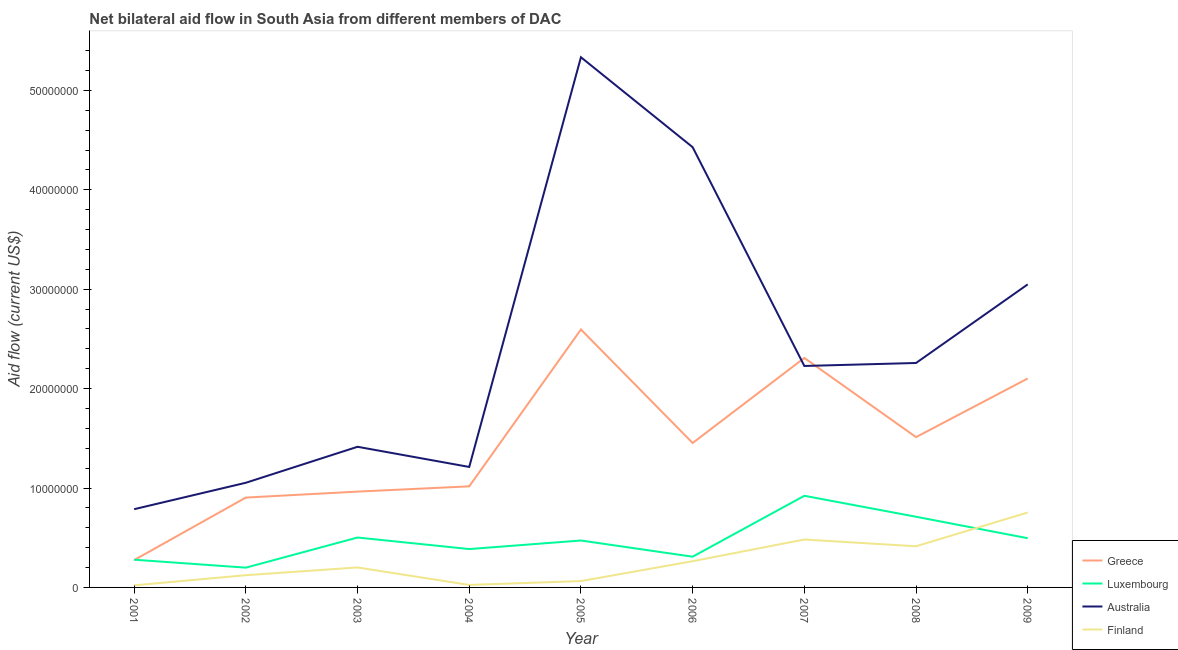What is the amount of aid given by finland in 2003?
Ensure brevity in your answer.  2.01e+06. Across all years, what is the maximum amount of aid given by australia?
Keep it short and to the point. 5.33e+07. Across all years, what is the minimum amount of aid given by finland?
Ensure brevity in your answer.  2.10e+05. In which year was the amount of aid given by greece maximum?
Make the answer very short. 2005. What is the total amount of aid given by greece in the graph?
Provide a succinct answer. 1.31e+08. What is the difference between the amount of aid given by luxembourg in 2003 and that in 2007?
Provide a succinct answer. -4.20e+06. What is the difference between the amount of aid given by australia in 2003 and the amount of aid given by finland in 2008?
Your answer should be compact. 1.00e+07. What is the average amount of aid given by luxembourg per year?
Offer a very short reply. 4.75e+06. In the year 2006, what is the difference between the amount of aid given by greece and amount of aid given by finland?
Provide a succinct answer. 1.19e+07. In how many years, is the amount of aid given by australia greater than 14000000 US$?
Offer a terse response. 6. What is the ratio of the amount of aid given by greece in 2002 to that in 2003?
Provide a succinct answer. 0.94. Is the amount of aid given by finland in 2002 less than that in 2007?
Provide a succinct answer. Yes. Is the difference between the amount of aid given by finland in 2003 and 2008 greater than the difference between the amount of aid given by australia in 2003 and 2008?
Keep it short and to the point. Yes. What is the difference between the highest and the second highest amount of aid given by luxembourg?
Your answer should be compact. 2.11e+06. What is the difference between the highest and the lowest amount of aid given by australia?
Give a very brief answer. 4.55e+07. In how many years, is the amount of aid given by greece greater than the average amount of aid given by greece taken over all years?
Give a very brief answer. 4. Is the sum of the amount of aid given by luxembourg in 2001 and 2004 greater than the maximum amount of aid given by greece across all years?
Offer a very short reply. No. Is it the case that in every year, the sum of the amount of aid given by greece and amount of aid given by luxembourg is greater than the amount of aid given by australia?
Give a very brief answer. No. Does the amount of aid given by australia monotonically increase over the years?
Provide a short and direct response. No. Does the graph contain any zero values?
Offer a very short reply. No. Does the graph contain grids?
Offer a terse response. No. How many legend labels are there?
Offer a terse response. 4. How are the legend labels stacked?
Provide a short and direct response. Vertical. What is the title of the graph?
Offer a very short reply. Net bilateral aid flow in South Asia from different members of DAC. What is the Aid flow (current US$) in Greece in 2001?
Keep it short and to the point. 2.75e+06. What is the Aid flow (current US$) of Luxembourg in 2001?
Offer a terse response. 2.79e+06. What is the Aid flow (current US$) of Australia in 2001?
Make the answer very short. 7.87e+06. What is the Aid flow (current US$) in Finland in 2001?
Your answer should be compact. 2.10e+05. What is the Aid flow (current US$) of Greece in 2002?
Provide a succinct answer. 9.04e+06. What is the Aid flow (current US$) in Luxembourg in 2002?
Your response must be concise. 1.99e+06. What is the Aid flow (current US$) of Australia in 2002?
Offer a terse response. 1.05e+07. What is the Aid flow (current US$) of Finland in 2002?
Offer a terse response. 1.23e+06. What is the Aid flow (current US$) of Greece in 2003?
Keep it short and to the point. 9.64e+06. What is the Aid flow (current US$) in Luxembourg in 2003?
Your response must be concise. 5.02e+06. What is the Aid flow (current US$) of Australia in 2003?
Offer a terse response. 1.42e+07. What is the Aid flow (current US$) in Finland in 2003?
Offer a very short reply. 2.01e+06. What is the Aid flow (current US$) in Greece in 2004?
Make the answer very short. 1.02e+07. What is the Aid flow (current US$) in Luxembourg in 2004?
Your answer should be compact. 3.86e+06. What is the Aid flow (current US$) of Australia in 2004?
Give a very brief answer. 1.21e+07. What is the Aid flow (current US$) in Greece in 2005?
Offer a very short reply. 2.60e+07. What is the Aid flow (current US$) in Luxembourg in 2005?
Offer a terse response. 4.72e+06. What is the Aid flow (current US$) in Australia in 2005?
Provide a short and direct response. 5.33e+07. What is the Aid flow (current US$) of Finland in 2005?
Keep it short and to the point. 6.40e+05. What is the Aid flow (current US$) of Greece in 2006?
Your answer should be very brief. 1.45e+07. What is the Aid flow (current US$) of Luxembourg in 2006?
Your response must be concise. 3.09e+06. What is the Aid flow (current US$) in Australia in 2006?
Your response must be concise. 4.43e+07. What is the Aid flow (current US$) in Finland in 2006?
Keep it short and to the point. 2.64e+06. What is the Aid flow (current US$) of Greece in 2007?
Make the answer very short. 2.31e+07. What is the Aid flow (current US$) in Luxembourg in 2007?
Provide a succinct answer. 9.22e+06. What is the Aid flow (current US$) in Australia in 2007?
Your answer should be very brief. 2.23e+07. What is the Aid flow (current US$) of Finland in 2007?
Give a very brief answer. 4.82e+06. What is the Aid flow (current US$) in Greece in 2008?
Provide a succinct answer. 1.51e+07. What is the Aid flow (current US$) in Luxembourg in 2008?
Offer a very short reply. 7.11e+06. What is the Aid flow (current US$) of Australia in 2008?
Make the answer very short. 2.26e+07. What is the Aid flow (current US$) in Finland in 2008?
Give a very brief answer. 4.14e+06. What is the Aid flow (current US$) of Greece in 2009?
Keep it short and to the point. 2.10e+07. What is the Aid flow (current US$) in Luxembourg in 2009?
Provide a short and direct response. 4.95e+06. What is the Aid flow (current US$) in Australia in 2009?
Provide a short and direct response. 3.05e+07. What is the Aid flow (current US$) of Finland in 2009?
Make the answer very short. 7.54e+06. Across all years, what is the maximum Aid flow (current US$) in Greece?
Offer a terse response. 2.60e+07. Across all years, what is the maximum Aid flow (current US$) in Luxembourg?
Give a very brief answer. 9.22e+06. Across all years, what is the maximum Aid flow (current US$) in Australia?
Your answer should be compact. 5.33e+07. Across all years, what is the maximum Aid flow (current US$) of Finland?
Your answer should be compact. 7.54e+06. Across all years, what is the minimum Aid flow (current US$) of Greece?
Your answer should be compact. 2.75e+06. Across all years, what is the minimum Aid flow (current US$) of Luxembourg?
Provide a short and direct response. 1.99e+06. Across all years, what is the minimum Aid flow (current US$) of Australia?
Keep it short and to the point. 7.87e+06. What is the total Aid flow (current US$) of Greece in the graph?
Offer a very short reply. 1.31e+08. What is the total Aid flow (current US$) of Luxembourg in the graph?
Keep it short and to the point. 4.28e+07. What is the total Aid flow (current US$) of Australia in the graph?
Your answer should be compact. 2.18e+08. What is the total Aid flow (current US$) of Finland in the graph?
Ensure brevity in your answer.  2.35e+07. What is the difference between the Aid flow (current US$) of Greece in 2001 and that in 2002?
Your response must be concise. -6.29e+06. What is the difference between the Aid flow (current US$) in Australia in 2001 and that in 2002?
Offer a terse response. -2.66e+06. What is the difference between the Aid flow (current US$) of Finland in 2001 and that in 2002?
Your answer should be very brief. -1.02e+06. What is the difference between the Aid flow (current US$) in Greece in 2001 and that in 2003?
Offer a terse response. -6.89e+06. What is the difference between the Aid flow (current US$) in Luxembourg in 2001 and that in 2003?
Offer a terse response. -2.23e+06. What is the difference between the Aid flow (current US$) of Australia in 2001 and that in 2003?
Give a very brief answer. -6.28e+06. What is the difference between the Aid flow (current US$) of Finland in 2001 and that in 2003?
Provide a short and direct response. -1.80e+06. What is the difference between the Aid flow (current US$) of Greece in 2001 and that in 2004?
Ensure brevity in your answer.  -7.42e+06. What is the difference between the Aid flow (current US$) in Luxembourg in 2001 and that in 2004?
Your response must be concise. -1.07e+06. What is the difference between the Aid flow (current US$) of Australia in 2001 and that in 2004?
Your answer should be very brief. -4.25e+06. What is the difference between the Aid flow (current US$) of Greece in 2001 and that in 2005?
Ensure brevity in your answer.  -2.32e+07. What is the difference between the Aid flow (current US$) of Luxembourg in 2001 and that in 2005?
Your response must be concise. -1.93e+06. What is the difference between the Aid flow (current US$) in Australia in 2001 and that in 2005?
Ensure brevity in your answer.  -4.55e+07. What is the difference between the Aid flow (current US$) of Finland in 2001 and that in 2005?
Offer a terse response. -4.30e+05. What is the difference between the Aid flow (current US$) of Greece in 2001 and that in 2006?
Ensure brevity in your answer.  -1.18e+07. What is the difference between the Aid flow (current US$) in Luxembourg in 2001 and that in 2006?
Provide a short and direct response. -3.00e+05. What is the difference between the Aid flow (current US$) of Australia in 2001 and that in 2006?
Your response must be concise. -3.64e+07. What is the difference between the Aid flow (current US$) in Finland in 2001 and that in 2006?
Offer a terse response. -2.43e+06. What is the difference between the Aid flow (current US$) in Greece in 2001 and that in 2007?
Your answer should be very brief. -2.03e+07. What is the difference between the Aid flow (current US$) in Luxembourg in 2001 and that in 2007?
Offer a very short reply. -6.43e+06. What is the difference between the Aid flow (current US$) of Australia in 2001 and that in 2007?
Ensure brevity in your answer.  -1.44e+07. What is the difference between the Aid flow (current US$) of Finland in 2001 and that in 2007?
Ensure brevity in your answer.  -4.61e+06. What is the difference between the Aid flow (current US$) in Greece in 2001 and that in 2008?
Your answer should be very brief. -1.24e+07. What is the difference between the Aid flow (current US$) of Luxembourg in 2001 and that in 2008?
Make the answer very short. -4.32e+06. What is the difference between the Aid flow (current US$) in Australia in 2001 and that in 2008?
Ensure brevity in your answer.  -1.47e+07. What is the difference between the Aid flow (current US$) of Finland in 2001 and that in 2008?
Provide a succinct answer. -3.93e+06. What is the difference between the Aid flow (current US$) of Greece in 2001 and that in 2009?
Give a very brief answer. -1.83e+07. What is the difference between the Aid flow (current US$) in Luxembourg in 2001 and that in 2009?
Provide a succinct answer. -2.16e+06. What is the difference between the Aid flow (current US$) of Australia in 2001 and that in 2009?
Ensure brevity in your answer.  -2.26e+07. What is the difference between the Aid flow (current US$) in Finland in 2001 and that in 2009?
Your answer should be compact. -7.33e+06. What is the difference between the Aid flow (current US$) of Greece in 2002 and that in 2003?
Give a very brief answer. -6.00e+05. What is the difference between the Aid flow (current US$) of Luxembourg in 2002 and that in 2003?
Keep it short and to the point. -3.03e+06. What is the difference between the Aid flow (current US$) of Australia in 2002 and that in 2003?
Your answer should be very brief. -3.62e+06. What is the difference between the Aid flow (current US$) of Finland in 2002 and that in 2003?
Offer a terse response. -7.80e+05. What is the difference between the Aid flow (current US$) in Greece in 2002 and that in 2004?
Your answer should be very brief. -1.13e+06. What is the difference between the Aid flow (current US$) in Luxembourg in 2002 and that in 2004?
Your answer should be very brief. -1.87e+06. What is the difference between the Aid flow (current US$) of Australia in 2002 and that in 2004?
Make the answer very short. -1.59e+06. What is the difference between the Aid flow (current US$) of Finland in 2002 and that in 2004?
Give a very brief answer. 9.80e+05. What is the difference between the Aid flow (current US$) in Greece in 2002 and that in 2005?
Make the answer very short. -1.69e+07. What is the difference between the Aid flow (current US$) in Luxembourg in 2002 and that in 2005?
Keep it short and to the point. -2.73e+06. What is the difference between the Aid flow (current US$) of Australia in 2002 and that in 2005?
Ensure brevity in your answer.  -4.28e+07. What is the difference between the Aid flow (current US$) in Finland in 2002 and that in 2005?
Your answer should be very brief. 5.90e+05. What is the difference between the Aid flow (current US$) in Greece in 2002 and that in 2006?
Provide a short and direct response. -5.49e+06. What is the difference between the Aid flow (current US$) in Luxembourg in 2002 and that in 2006?
Your answer should be compact. -1.10e+06. What is the difference between the Aid flow (current US$) in Australia in 2002 and that in 2006?
Provide a succinct answer. -3.38e+07. What is the difference between the Aid flow (current US$) of Finland in 2002 and that in 2006?
Your answer should be compact. -1.41e+06. What is the difference between the Aid flow (current US$) in Greece in 2002 and that in 2007?
Make the answer very short. -1.40e+07. What is the difference between the Aid flow (current US$) in Luxembourg in 2002 and that in 2007?
Keep it short and to the point. -7.23e+06. What is the difference between the Aid flow (current US$) of Australia in 2002 and that in 2007?
Make the answer very short. -1.18e+07. What is the difference between the Aid flow (current US$) in Finland in 2002 and that in 2007?
Your answer should be compact. -3.59e+06. What is the difference between the Aid flow (current US$) in Greece in 2002 and that in 2008?
Your answer should be compact. -6.08e+06. What is the difference between the Aid flow (current US$) in Luxembourg in 2002 and that in 2008?
Your response must be concise. -5.12e+06. What is the difference between the Aid flow (current US$) of Australia in 2002 and that in 2008?
Your response must be concise. -1.20e+07. What is the difference between the Aid flow (current US$) of Finland in 2002 and that in 2008?
Your response must be concise. -2.91e+06. What is the difference between the Aid flow (current US$) in Greece in 2002 and that in 2009?
Make the answer very short. -1.20e+07. What is the difference between the Aid flow (current US$) in Luxembourg in 2002 and that in 2009?
Provide a short and direct response. -2.96e+06. What is the difference between the Aid flow (current US$) of Australia in 2002 and that in 2009?
Keep it short and to the point. -2.00e+07. What is the difference between the Aid flow (current US$) in Finland in 2002 and that in 2009?
Make the answer very short. -6.31e+06. What is the difference between the Aid flow (current US$) of Greece in 2003 and that in 2004?
Provide a short and direct response. -5.30e+05. What is the difference between the Aid flow (current US$) of Luxembourg in 2003 and that in 2004?
Ensure brevity in your answer.  1.16e+06. What is the difference between the Aid flow (current US$) of Australia in 2003 and that in 2004?
Give a very brief answer. 2.03e+06. What is the difference between the Aid flow (current US$) of Finland in 2003 and that in 2004?
Provide a succinct answer. 1.76e+06. What is the difference between the Aid flow (current US$) of Greece in 2003 and that in 2005?
Offer a very short reply. -1.63e+07. What is the difference between the Aid flow (current US$) in Australia in 2003 and that in 2005?
Give a very brief answer. -3.92e+07. What is the difference between the Aid flow (current US$) in Finland in 2003 and that in 2005?
Provide a succinct answer. 1.37e+06. What is the difference between the Aid flow (current US$) of Greece in 2003 and that in 2006?
Keep it short and to the point. -4.89e+06. What is the difference between the Aid flow (current US$) of Luxembourg in 2003 and that in 2006?
Your answer should be compact. 1.93e+06. What is the difference between the Aid flow (current US$) in Australia in 2003 and that in 2006?
Ensure brevity in your answer.  -3.01e+07. What is the difference between the Aid flow (current US$) of Finland in 2003 and that in 2006?
Offer a terse response. -6.30e+05. What is the difference between the Aid flow (current US$) in Greece in 2003 and that in 2007?
Your response must be concise. -1.34e+07. What is the difference between the Aid flow (current US$) in Luxembourg in 2003 and that in 2007?
Provide a short and direct response. -4.20e+06. What is the difference between the Aid flow (current US$) of Australia in 2003 and that in 2007?
Your answer should be compact. -8.13e+06. What is the difference between the Aid flow (current US$) of Finland in 2003 and that in 2007?
Offer a very short reply. -2.81e+06. What is the difference between the Aid flow (current US$) of Greece in 2003 and that in 2008?
Offer a terse response. -5.48e+06. What is the difference between the Aid flow (current US$) in Luxembourg in 2003 and that in 2008?
Provide a short and direct response. -2.09e+06. What is the difference between the Aid flow (current US$) in Australia in 2003 and that in 2008?
Provide a short and direct response. -8.43e+06. What is the difference between the Aid flow (current US$) in Finland in 2003 and that in 2008?
Your response must be concise. -2.13e+06. What is the difference between the Aid flow (current US$) of Greece in 2003 and that in 2009?
Offer a terse response. -1.14e+07. What is the difference between the Aid flow (current US$) of Luxembourg in 2003 and that in 2009?
Your response must be concise. 7.00e+04. What is the difference between the Aid flow (current US$) of Australia in 2003 and that in 2009?
Provide a succinct answer. -1.63e+07. What is the difference between the Aid flow (current US$) of Finland in 2003 and that in 2009?
Keep it short and to the point. -5.53e+06. What is the difference between the Aid flow (current US$) in Greece in 2004 and that in 2005?
Keep it short and to the point. -1.58e+07. What is the difference between the Aid flow (current US$) in Luxembourg in 2004 and that in 2005?
Keep it short and to the point. -8.60e+05. What is the difference between the Aid flow (current US$) in Australia in 2004 and that in 2005?
Provide a succinct answer. -4.12e+07. What is the difference between the Aid flow (current US$) in Finland in 2004 and that in 2005?
Give a very brief answer. -3.90e+05. What is the difference between the Aid flow (current US$) of Greece in 2004 and that in 2006?
Provide a succinct answer. -4.36e+06. What is the difference between the Aid flow (current US$) of Luxembourg in 2004 and that in 2006?
Offer a very short reply. 7.70e+05. What is the difference between the Aid flow (current US$) in Australia in 2004 and that in 2006?
Keep it short and to the point. -3.22e+07. What is the difference between the Aid flow (current US$) of Finland in 2004 and that in 2006?
Provide a short and direct response. -2.39e+06. What is the difference between the Aid flow (current US$) of Greece in 2004 and that in 2007?
Ensure brevity in your answer.  -1.29e+07. What is the difference between the Aid flow (current US$) in Luxembourg in 2004 and that in 2007?
Give a very brief answer. -5.36e+06. What is the difference between the Aid flow (current US$) of Australia in 2004 and that in 2007?
Provide a succinct answer. -1.02e+07. What is the difference between the Aid flow (current US$) in Finland in 2004 and that in 2007?
Offer a terse response. -4.57e+06. What is the difference between the Aid flow (current US$) of Greece in 2004 and that in 2008?
Offer a terse response. -4.95e+06. What is the difference between the Aid flow (current US$) in Luxembourg in 2004 and that in 2008?
Offer a very short reply. -3.25e+06. What is the difference between the Aid flow (current US$) of Australia in 2004 and that in 2008?
Offer a very short reply. -1.05e+07. What is the difference between the Aid flow (current US$) in Finland in 2004 and that in 2008?
Offer a terse response. -3.89e+06. What is the difference between the Aid flow (current US$) of Greece in 2004 and that in 2009?
Your response must be concise. -1.08e+07. What is the difference between the Aid flow (current US$) in Luxembourg in 2004 and that in 2009?
Ensure brevity in your answer.  -1.09e+06. What is the difference between the Aid flow (current US$) of Australia in 2004 and that in 2009?
Offer a very short reply. -1.84e+07. What is the difference between the Aid flow (current US$) in Finland in 2004 and that in 2009?
Your answer should be compact. -7.29e+06. What is the difference between the Aid flow (current US$) of Greece in 2005 and that in 2006?
Provide a succinct answer. 1.14e+07. What is the difference between the Aid flow (current US$) of Luxembourg in 2005 and that in 2006?
Your answer should be compact. 1.63e+06. What is the difference between the Aid flow (current US$) in Australia in 2005 and that in 2006?
Your answer should be compact. 9.05e+06. What is the difference between the Aid flow (current US$) in Greece in 2005 and that in 2007?
Offer a very short reply. 2.86e+06. What is the difference between the Aid flow (current US$) in Luxembourg in 2005 and that in 2007?
Provide a short and direct response. -4.50e+06. What is the difference between the Aid flow (current US$) in Australia in 2005 and that in 2007?
Offer a very short reply. 3.11e+07. What is the difference between the Aid flow (current US$) in Finland in 2005 and that in 2007?
Give a very brief answer. -4.18e+06. What is the difference between the Aid flow (current US$) in Greece in 2005 and that in 2008?
Ensure brevity in your answer.  1.08e+07. What is the difference between the Aid flow (current US$) of Luxembourg in 2005 and that in 2008?
Your answer should be very brief. -2.39e+06. What is the difference between the Aid flow (current US$) in Australia in 2005 and that in 2008?
Keep it short and to the point. 3.08e+07. What is the difference between the Aid flow (current US$) in Finland in 2005 and that in 2008?
Provide a succinct answer. -3.50e+06. What is the difference between the Aid flow (current US$) of Greece in 2005 and that in 2009?
Keep it short and to the point. 4.93e+06. What is the difference between the Aid flow (current US$) of Luxembourg in 2005 and that in 2009?
Ensure brevity in your answer.  -2.30e+05. What is the difference between the Aid flow (current US$) in Australia in 2005 and that in 2009?
Your answer should be compact. 2.28e+07. What is the difference between the Aid flow (current US$) of Finland in 2005 and that in 2009?
Provide a succinct answer. -6.90e+06. What is the difference between the Aid flow (current US$) in Greece in 2006 and that in 2007?
Provide a short and direct response. -8.56e+06. What is the difference between the Aid flow (current US$) in Luxembourg in 2006 and that in 2007?
Your answer should be very brief. -6.13e+06. What is the difference between the Aid flow (current US$) in Australia in 2006 and that in 2007?
Provide a short and direct response. 2.20e+07. What is the difference between the Aid flow (current US$) in Finland in 2006 and that in 2007?
Your response must be concise. -2.18e+06. What is the difference between the Aid flow (current US$) of Greece in 2006 and that in 2008?
Your answer should be compact. -5.90e+05. What is the difference between the Aid flow (current US$) of Luxembourg in 2006 and that in 2008?
Your answer should be compact. -4.02e+06. What is the difference between the Aid flow (current US$) in Australia in 2006 and that in 2008?
Your response must be concise. 2.17e+07. What is the difference between the Aid flow (current US$) of Finland in 2006 and that in 2008?
Provide a succinct answer. -1.50e+06. What is the difference between the Aid flow (current US$) in Greece in 2006 and that in 2009?
Your answer should be very brief. -6.49e+06. What is the difference between the Aid flow (current US$) of Luxembourg in 2006 and that in 2009?
Provide a short and direct response. -1.86e+06. What is the difference between the Aid flow (current US$) of Australia in 2006 and that in 2009?
Your response must be concise. 1.38e+07. What is the difference between the Aid flow (current US$) of Finland in 2006 and that in 2009?
Your answer should be very brief. -4.90e+06. What is the difference between the Aid flow (current US$) in Greece in 2007 and that in 2008?
Offer a very short reply. 7.97e+06. What is the difference between the Aid flow (current US$) in Luxembourg in 2007 and that in 2008?
Ensure brevity in your answer.  2.11e+06. What is the difference between the Aid flow (current US$) in Australia in 2007 and that in 2008?
Offer a very short reply. -3.00e+05. What is the difference between the Aid flow (current US$) of Finland in 2007 and that in 2008?
Provide a short and direct response. 6.80e+05. What is the difference between the Aid flow (current US$) of Greece in 2007 and that in 2009?
Offer a terse response. 2.07e+06. What is the difference between the Aid flow (current US$) in Luxembourg in 2007 and that in 2009?
Your answer should be very brief. 4.27e+06. What is the difference between the Aid flow (current US$) in Australia in 2007 and that in 2009?
Ensure brevity in your answer.  -8.21e+06. What is the difference between the Aid flow (current US$) in Finland in 2007 and that in 2009?
Make the answer very short. -2.72e+06. What is the difference between the Aid flow (current US$) of Greece in 2008 and that in 2009?
Your answer should be very brief. -5.90e+06. What is the difference between the Aid flow (current US$) in Luxembourg in 2008 and that in 2009?
Make the answer very short. 2.16e+06. What is the difference between the Aid flow (current US$) of Australia in 2008 and that in 2009?
Keep it short and to the point. -7.91e+06. What is the difference between the Aid flow (current US$) in Finland in 2008 and that in 2009?
Provide a short and direct response. -3.40e+06. What is the difference between the Aid flow (current US$) of Greece in 2001 and the Aid flow (current US$) of Luxembourg in 2002?
Provide a short and direct response. 7.60e+05. What is the difference between the Aid flow (current US$) of Greece in 2001 and the Aid flow (current US$) of Australia in 2002?
Keep it short and to the point. -7.78e+06. What is the difference between the Aid flow (current US$) of Greece in 2001 and the Aid flow (current US$) of Finland in 2002?
Provide a short and direct response. 1.52e+06. What is the difference between the Aid flow (current US$) of Luxembourg in 2001 and the Aid flow (current US$) of Australia in 2002?
Your answer should be very brief. -7.74e+06. What is the difference between the Aid flow (current US$) of Luxembourg in 2001 and the Aid flow (current US$) of Finland in 2002?
Provide a succinct answer. 1.56e+06. What is the difference between the Aid flow (current US$) of Australia in 2001 and the Aid flow (current US$) of Finland in 2002?
Provide a short and direct response. 6.64e+06. What is the difference between the Aid flow (current US$) of Greece in 2001 and the Aid flow (current US$) of Luxembourg in 2003?
Offer a terse response. -2.27e+06. What is the difference between the Aid flow (current US$) in Greece in 2001 and the Aid flow (current US$) in Australia in 2003?
Offer a terse response. -1.14e+07. What is the difference between the Aid flow (current US$) in Greece in 2001 and the Aid flow (current US$) in Finland in 2003?
Offer a terse response. 7.40e+05. What is the difference between the Aid flow (current US$) of Luxembourg in 2001 and the Aid flow (current US$) of Australia in 2003?
Give a very brief answer. -1.14e+07. What is the difference between the Aid flow (current US$) in Luxembourg in 2001 and the Aid flow (current US$) in Finland in 2003?
Ensure brevity in your answer.  7.80e+05. What is the difference between the Aid flow (current US$) in Australia in 2001 and the Aid flow (current US$) in Finland in 2003?
Your answer should be compact. 5.86e+06. What is the difference between the Aid flow (current US$) of Greece in 2001 and the Aid flow (current US$) of Luxembourg in 2004?
Ensure brevity in your answer.  -1.11e+06. What is the difference between the Aid flow (current US$) in Greece in 2001 and the Aid flow (current US$) in Australia in 2004?
Give a very brief answer. -9.37e+06. What is the difference between the Aid flow (current US$) in Greece in 2001 and the Aid flow (current US$) in Finland in 2004?
Keep it short and to the point. 2.50e+06. What is the difference between the Aid flow (current US$) of Luxembourg in 2001 and the Aid flow (current US$) of Australia in 2004?
Give a very brief answer. -9.33e+06. What is the difference between the Aid flow (current US$) in Luxembourg in 2001 and the Aid flow (current US$) in Finland in 2004?
Make the answer very short. 2.54e+06. What is the difference between the Aid flow (current US$) of Australia in 2001 and the Aid flow (current US$) of Finland in 2004?
Provide a succinct answer. 7.62e+06. What is the difference between the Aid flow (current US$) in Greece in 2001 and the Aid flow (current US$) in Luxembourg in 2005?
Make the answer very short. -1.97e+06. What is the difference between the Aid flow (current US$) of Greece in 2001 and the Aid flow (current US$) of Australia in 2005?
Keep it short and to the point. -5.06e+07. What is the difference between the Aid flow (current US$) of Greece in 2001 and the Aid flow (current US$) of Finland in 2005?
Your response must be concise. 2.11e+06. What is the difference between the Aid flow (current US$) of Luxembourg in 2001 and the Aid flow (current US$) of Australia in 2005?
Your answer should be compact. -5.06e+07. What is the difference between the Aid flow (current US$) in Luxembourg in 2001 and the Aid flow (current US$) in Finland in 2005?
Ensure brevity in your answer.  2.15e+06. What is the difference between the Aid flow (current US$) of Australia in 2001 and the Aid flow (current US$) of Finland in 2005?
Your answer should be compact. 7.23e+06. What is the difference between the Aid flow (current US$) in Greece in 2001 and the Aid flow (current US$) in Australia in 2006?
Give a very brief answer. -4.15e+07. What is the difference between the Aid flow (current US$) of Luxembourg in 2001 and the Aid flow (current US$) of Australia in 2006?
Provide a short and direct response. -4.15e+07. What is the difference between the Aid flow (current US$) in Luxembourg in 2001 and the Aid flow (current US$) in Finland in 2006?
Your answer should be compact. 1.50e+05. What is the difference between the Aid flow (current US$) in Australia in 2001 and the Aid flow (current US$) in Finland in 2006?
Offer a terse response. 5.23e+06. What is the difference between the Aid flow (current US$) in Greece in 2001 and the Aid flow (current US$) in Luxembourg in 2007?
Ensure brevity in your answer.  -6.47e+06. What is the difference between the Aid flow (current US$) of Greece in 2001 and the Aid flow (current US$) of Australia in 2007?
Your answer should be very brief. -1.95e+07. What is the difference between the Aid flow (current US$) of Greece in 2001 and the Aid flow (current US$) of Finland in 2007?
Offer a terse response. -2.07e+06. What is the difference between the Aid flow (current US$) in Luxembourg in 2001 and the Aid flow (current US$) in Australia in 2007?
Provide a short and direct response. -1.95e+07. What is the difference between the Aid flow (current US$) in Luxembourg in 2001 and the Aid flow (current US$) in Finland in 2007?
Your answer should be compact. -2.03e+06. What is the difference between the Aid flow (current US$) of Australia in 2001 and the Aid flow (current US$) of Finland in 2007?
Provide a short and direct response. 3.05e+06. What is the difference between the Aid flow (current US$) of Greece in 2001 and the Aid flow (current US$) of Luxembourg in 2008?
Your answer should be very brief. -4.36e+06. What is the difference between the Aid flow (current US$) in Greece in 2001 and the Aid flow (current US$) in Australia in 2008?
Give a very brief answer. -1.98e+07. What is the difference between the Aid flow (current US$) in Greece in 2001 and the Aid flow (current US$) in Finland in 2008?
Offer a terse response. -1.39e+06. What is the difference between the Aid flow (current US$) in Luxembourg in 2001 and the Aid flow (current US$) in Australia in 2008?
Your answer should be compact. -1.98e+07. What is the difference between the Aid flow (current US$) in Luxembourg in 2001 and the Aid flow (current US$) in Finland in 2008?
Offer a very short reply. -1.35e+06. What is the difference between the Aid flow (current US$) in Australia in 2001 and the Aid flow (current US$) in Finland in 2008?
Your response must be concise. 3.73e+06. What is the difference between the Aid flow (current US$) of Greece in 2001 and the Aid flow (current US$) of Luxembourg in 2009?
Keep it short and to the point. -2.20e+06. What is the difference between the Aid flow (current US$) in Greece in 2001 and the Aid flow (current US$) in Australia in 2009?
Ensure brevity in your answer.  -2.77e+07. What is the difference between the Aid flow (current US$) in Greece in 2001 and the Aid flow (current US$) in Finland in 2009?
Make the answer very short. -4.79e+06. What is the difference between the Aid flow (current US$) in Luxembourg in 2001 and the Aid flow (current US$) in Australia in 2009?
Make the answer very short. -2.77e+07. What is the difference between the Aid flow (current US$) of Luxembourg in 2001 and the Aid flow (current US$) of Finland in 2009?
Make the answer very short. -4.75e+06. What is the difference between the Aid flow (current US$) of Australia in 2001 and the Aid flow (current US$) of Finland in 2009?
Provide a short and direct response. 3.30e+05. What is the difference between the Aid flow (current US$) in Greece in 2002 and the Aid flow (current US$) in Luxembourg in 2003?
Your answer should be compact. 4.02e+06. What is the difference between the Aid flow (current US$) of Greece in 2002 and the Aid flow (current US$) of Australia in 2003?
Your answer should be very brief. -5.11e+06. What is the difference between the Aid flow (current US$) of Greece in 2002 and the Aid flow (current US$) of Finland in 2003?
Your answer should be compact. 7.03e+06. What is the difference between the Aid flow (current US$) of Luxembourg in 2002 and the Aid flow (current US$) of Australia in 2003?
Offer a very short reply. -1.22e+07. What is the difference between the Aid flow (current US$) of Australia in 2002 and the Aid flow (current US$) of Finland in 2003?
Keep it short and to the point. 8.52e+06. What is the difference between the Aid flow (current US$) of Greece in 2002 and the Aid flow (current US$) of Luxembourg in 2004?
Offer a very short reply. 5.18e+06. What is the difference between the Aid flow (current US$) of Greece in 2002 and the Aid flow (current US$) of Australia in 2004?
Make the answer very short. -3.08e+06. What is the difference between the Aid flow (current US$) in Greece in 2002 and the Aid flow (current US$) in Finland in 2004?
Provide a short and direct response. 8.79e+06. What is the difference between the Aid flow (current US$) in Luxembourg in 2002 and the Aid flow (current US$) in Australia in 2004?
Your answer should be compact. -1.01e+07. What is the difference between the Aid flow (current US$) in Luxembourg in 2002 and the Aid flow (current US$) in Finland in 2004?
Offer a very short reply. 1.74e+06. What is the difference between the Aid flow (current US$) in Australia in 2002 and the Aid flow (current US$) in Finland in 2004?
Your answer should be compact. 1.03e+07. What is the difference between the Aid flow (current US$) of Greece in 2002 and the Aid flow (current US$) of Luxembourg in 2005?
Ensure brevity in your answer.  4.32e+06. What is the difference between the Aid flow (current US$) of Greece in 2002 and the Aid flow (current US$) of Australia in 2005?
Make the answer very short. -4.43e+07. What is the difference between the Aid flow (current US$) in Greece in 2002 and the Aid flow (current US$) in Finland in 2005?
Provide a short and direct response. 8.40e+06. What is the difference between the Aid flow (current US$) in Luxembourg in 2002 and the Aid flow (current US$) in Australia in 2005?
Offer a very short reply. -5.14e+07. What is the difference between the Aid flow (current US$) in Luxembourg in 2002 and the Aid flow (current US$) in Finland in 2005?
Give a very brief answer. 1.35e+06. What is the difference between the Aid flow (current US$) in Australia in 2002 and the Aid flow (current US$) in Finland in 2005?
Provide a succinct answer. 9.89e+06. What is the difference between the Aid flow (current US$) in Greece in 2002 and the Aid flow (current US$) in Luxembourg in 2006?
Provide a short and direct response. 5.95e+06. What is the difference between the Aid flow (current US$) in Greece in 2002 and the Aid flow (current US$) in Australia in 2006?
Ensure brevity in your answer.  -3.52e+07. What is the difference between the Aid flow (current US$) in Greece in 2002 and the Aid flow (current US$) in Finland in 2006?
Make the answer very short. 6.40e+06. What is the difference between the Aid flow (current US$) of Luxembourg in 2002 and the Aid flow (current US$) of Australia in 2006?
Provide a short and direct response. -4.23e+07. What is the difference between the Aid flow (current US$) in Luxembourg in 2002 and the Aid flow (current US$) in Finland in 2006?
Offer a very short reply. -6.50e+05. What is the difference between the Aid flow (current US$) in Australia in 2002 and the Aid flow (current US$) in Finland in 2006?
Your response must be concise. 7.89e+06. What is the difference between the Aid flow (current US$) in Greece in 2002 and the Aid flow (current US$) in Luxembourg in 2007?
Provide a succinct answer. -1.80e+05. What is the difference between the Aid flow (current US$) in Greece in 2002 and the Aid flow (current US$) in Australia in 2007?
Offer a terse response. -1.32e+07. What is the difference between the Aid flow (current US$) in Greece in 2002 and the Aid flow (current US$) in Finland in 2007?
Offer a very short reply. 4.22e+06. What is the difference between the Aid flow (current US$) of Luxembourg in 2002 and the Aid flow (current US$) of Australia in 2007?
Provide a short and direct response. -2.03e+07. What is the difference between the Aid flow (current US$) in Luxembourg in 2002 and the Aid flow (current US$) in Finland in 2007?
Your answer should be very brief. -2.83e+06. What is the difference between the Aid flow (current US$) in Australia in 2002 and the Aid flow (current US$) in Finland in 2007?
Ensure brevity in your answer.  5.71e+06. What is the difference between the Aid flow (current US$) in Greece in 2002 and the Aid flow (current US$) in Luxembourg in 2008?
Offer a terse response. 1.93e+06. What is the difference between the Aid flow (current US$) of Greece in 2002 and the Aid flow (current US$) of Australia in 2008?
Provide a succinct answer. -1.35e+07. What is the difference between the Aid flow (current US$) of Greece in 2002 and the Aid flow (current US$) of Finland in 2008?
Keep it short and to the point. 4.90e+06. What is the difference between the Aid flow (current US$) in Luxembourg in 2002 and the Aid flow (current US$) in Australia in 2008?
Keep it short and to the point. -2.06e+07. What is the difference between the Aid flow (current US$) in Luxembourg in 2002 and the Aid flow (current US$) in Finland in 2008?
Ensure brevity in your answer.  -2.15e+06. What is the difference between the Aid flow (current US$) in Australia in 2002 and the Aid flow (current US$) in Finland in 2008?
Make the answer very short. 6.39e+06. What is the difference between the Aid flow (current US$) in Greece in 2002 and the Aid flow (current US$) in Luxembourg in 2009?
Keep it short and to the point. 4.09e+06. What is the difference between the Aid flow (current US$) in Greece in 2002 and the Aid flow (current US$) in Australia in 2009?
Provide a short and direct response. -2.14e+07. What is the difference between the Aid flow (current US$) of Greece in 2002 and the Aid flow (current US$) of Finland in 2009?
Make the answer very short. 1.50e+06. What is the difference between the Aid flow (current US$) of Luxembourg in 2002 and the Aid flow (current US$) of Australia in 2009?
Give a very brief answer. -2.85e+07. What is the difference between the Aid flow (current US$) of Luxembourg in 2002 and the Aid flow (current US$) of Finland in 2009?
Offer a terse response. -5.55e+06. What is the difference between the Aid flow (current US$) of Australia in 2002 and the Aid flow (current US$) of Finland in 2009?
Keep it short and to the point. 2.99e+06. What is the difference between the Aid flow (current US$) in Greece in 2003 and the Aid flow (current US$) in Luxembourg in 2004?
Offer a terse response. 5.78e+06. What is the difference between the Aid flow (current US$) in Greece in 2003 and the Aid flow (current US$) in Australia in 2004?
Offer a very short reply. -2.48e+06. What is the difference between the Aid flow (current US$) in Greece in 2003 and the Aid flow (current US$) in Finland in 2004?
Ensure brevity in your answer.  9.39e+06. What is the difference between the Aid flow (current US$) of Luxembourg in 2003 and the Aid flow (current US$) of Australia in 2004?
Offer a very short reply. -7.10e+06. What is the difference between the Aid flow (current US$) in Luxembourg in 2003 and the Aid flow (current US$) in Finland in 2004?
Ensure brevity in your answer.  4.77e+06. What is the difference between the Aid flow (current US$) in Australia in 2003 and the Aid flow (current US$) in Finland in 2004?
Your answer should be very brief. 1.39e+07. What is the difference between the Aid flow (current US$) of Greece in 2003 and the Aid flow (current US$) of Luxembourg in 2005?
Your answer should be very brief. 4.92e+06. What is the difference between the Aid flow (current US$) in Greece in 2003 and the Aid flow (current US$) in Australia in 2005?
Give a very brief answer. -4.37e+07. What is the difference between the Aid flow (current US$) in Greece in 2003 and the Aid flow (current US$) in Finland in 2005?
Offer a terse response. 9.00e+06. What is the difference between the Aid flow (current US$) of Luxembourg in 2003 and the Aid flow (current US$) of Australia in 2005?
Offer a terse response. -4.83e+07. What is the difference between the Aid flow (current US$) in Luxembourg in 2003 and the Aid flow (current US$) in Finland in 2005?
Keep it short and to the point. 4.38e+06. What is the difference between the Aid flow (current US$) in Australia in 2003 and the Aid flow (current US$) in Finland in 2005?
Give a very brief answer. 1.35e+07. What is the difference between the Aid flow (current US$) in Greece in 2003 and the Aid flow (current US$) in Luxembourg in 2006?
Make the answer very short. 6.55e+06. What is the difference between the Aid flow (current US$) in Greece in 2003 and the Aid flow (current US$) in Australia in 2006?
Your response must be concise. -3.46e+07. What is the difference between the Aid flow (current US$) in Luxembourg in 2003 and the Aid flow (current US$) in Australia in 2006?
Offer a terse response. -3.93e+07. What is the difference between the Aid flow (current US$) in Luxembourg in 2003 and the Aid flow (current US$) in Finland in 2006?
Provide a succinct answer. 2.38e+06. What is the difference between the Aid flow (current US$) of Australia in 2003 and the Aid flow (current US$) of Finland in 2006?
Offer a very short reply. 1.15e+07. What is the difference between the Aid flow (current US$) of Greece in 2003 and the Aid flow (current US$) of Luxembourg in 2007?
Your response must be concise. 4.20e+05. What is the difference between the Aid flow (current US$) of Greece in 2003 and the Aid flow (current US$) of Australia in 2007?
Your answer should be compact. -1.26e+07. What is the difference between the Aid flow (current US$) of Greece in 2003 and the Aid flow (current US$) of Finland in 2007?
Offer a terse response. 4.82e+06. What is the difference between the Aid flow (current US$) of Luxembourg in 2003 and the Aid flow (current US$) of Australia in 2007?
Make the answer very short. -1.73e+07. What is the difference between the Aid flow (current US$) in Luxembourg in 2003 and the Aid flow (current US$) in Finland in 2007?
Your answer should be very brief. 2.00e+05. What is the difference between the Aid flow (current US$) in Australia in 2003 and the Aid flow (current US$) in Finland in 2007?
Ensure brevity in your answer.  9.33e+06. What is the difference between the Aid flow (current US$) in Greece in 2003 and the Aid flow (current US$) in Luxembourg in 2008?
Your answer should be compact. 2.53e+06. What is the difference between the Aid flow (current US$) of Greece in 2003 and the Aid flow (current US$) of Australia in 2008?
Your answer should be very brief. -1.29e+07. What is the difference between the Aid flow (current US$) of Greece in 2003 and the Aid flow (current US$) of Finland in 2008?
Offer a terse response. 5.50e+06. What is the difference between the Aid flow (current US$) of Luxembourg in 2003 and the Aid flow (current US$) of Australia in 2008?
Your answer should be very brief. -1.76e+07. What is the difference between the Aid flow (current US$) in Luxembourg in 2003 and the Aid flow (current US$) in Finland in 2008?
Offer a terse response. 8.80e+05. What is the difference between the Aid flow (current US$) in Australia in 2003 and the Aid flow (current US$) in Finland in 2008?
Keep it short and to the point. 1.00e+07. What is the difference between the Aid flow (current US$) in Greece in 2003 and the Aid flow (current US$) in Luxembourg in 2009?
Ensure brevity in your answer.  4.69e+06. What is the difference between the Aid flow (current US$) of Greece in 2003 and the Aid flow (current US$) of Australia in 2009?
Your response must be concise. -2.08e+07. What is the difference between the Aid flow (current US$) in Greece in 2003 and the Aid flow (current US$) in Finland in 2009?
Your response must be concise. 2.10e+06. What is the difference between the Aid flow (current US$) of Luxembourg in 2003 and the Aid flow (current US$) of Australia in 2009?
Your answer should be compact. -2.55e+07. What is the difference between the Aid flow (current US$) of Luxembourg in 2003 and the Aid flow (current US$) of Finland in 2009?
Provide a short and direct response. -2.52e+06. What is the difference between the Aid flow (current US$) in Australia in 2003 and the Aid flow (current US$) in Finland in 2009?
Ensure brevity in your answer.  6.61e+06. What is the difference between the Aid flow (current US$) of Greece in 2004 and the Aid flow (current US$) of Luxembourg in 2005?
Your response must be concise. 5.45e+06. What is the difference between the Aid flow (current US$) in Greece in 2004 and the Aid flow (current US$) in Australia in 2005?
Provide a succinct answer. -4.32e+07. What is the difference between the Aid flow (current US$) of Greece in 2004 and the Aid flow (current US$) of Finland in 2005?
Your response must be concise. 9.53e+06. What is the difference between the Aid flow (current US$) in Luxembourg in 2004 and the Aid flow (current US$) in Australia in 2005?
Keep it short and to the point. -4.95e+07. What is the difference between the Aid flow (current US$) in Luxembourg in 2004 and the Aid flow (current US$) in Finland in 2005?
Ensure brevity in your answer.  3.22e+06. What is the difference between the Aid flow (current US$) in Australia in 2004 and the Aid flow (current US$) in Finland in 2005?
Your answer should be compact. 1.15e+07. What is the difference between the Aid flow (current US$) in Greece in 2004 and the Aid flow (current US$) in Luxembourg in 2006?
Offer a very short reply. 7.08e+06. What is the difference between the Aid flow (current US$) of Greece in 2004 and the Aid flow (current US$) of Australia in 2006?
Ensure brevity in your answer.  -3.41e+07. What is the difference between the Aid flow (current US$) in Greece in 2004 and the Aid flow (current US$) in Finland in 2006?
Your answer should be very brief. 7.53e+06. What is the difference between the Aid flow (current US$) of Luxembourg in 2004 and the Aid flow (current US$) of Australia in 2006?
Make the answer very short. -4.04e+07. What is the difference between the Aid flow (current US$) in Luxembourg in 2004 and the Aid flow (current US$) in Finland in 2006?
Your answer should be very brief. 1.22e+06. What is the difference between the Aid flow (current US$) in Australia in 2004 and the Aid flow (current US$) in Finland in 2006?
Your answer should be very brief. 9.48e+06. What is the difference between the Aid flow (current US$) in Greece in 2004 and the Aid flow (current US$) in Luxembourg in 2007?
Give a very brief answer. 9.50e+05. What is the difference between the Aid flow (current US$) in Greece in 2004 and the Aid flow (current US$) in Australia in 2007?
Provide a short and direct response. -1.21e+07. What is the difference between the Aid flow (current US$) in Greece in 2004 and the Aid flow (current US$) in Finland in 2007?
Provide a short and direct response. 5.35e+06. What is the difference between the Aid flow (current US$) of Luxembourg in 2004 and the Aid flow (current US$) of Australia in 2007?
Offer a terse response. -1.84e+07. What is the difference between the Aid flow (current US$) of Luxembourg in 2004 and the Aid flow (current US$) of Finland in 2007?
Provide a short and direct response. -9.60e+05. What is the difference between the Aid flow (current US$) in Australia in 2004 and the Aid flow (current US$) in Finland in 2007?
Provide a short and direct response. 7.30e+06. What is the difference between the Aid flow (current US$) of Greece in 2004 and the Aid flow (current US$) of Luxembourg in 2008?
Offer a very short reply. 3.06e+06. What is the difference between the Aid flow (current US$) in Greece in 2004 and the Aid flow (current US$) in Australia in 2008?
Your answer should be compact. -1.24e+07. What is the difference between the Aid flow (current US$) in Greece in 2004 and the Aid flow (current US$) in Finland in 2008?
Your answer should be compact. 6.03e+06. What is the difference between the Aid flow (current US$) in Luxembourg in 2004 and the Aid flow (current US$) in Australia in 2008?
Offer a very short reply. -1.87e+07. What is the difference between the Aid flow (current US$) of Luxembourg in 2004 and the Aid flow (current US$) of Finland in 2008?
Provide a short and direct response. -2.80e+05. What is the difference between the Aid flow (current US$) in Australia in 2004 and the Aid flow (current US$) in Finland in 2008?
Your answer should be very brief. 7.98e+06. What is the difference between the Aid flow (current US$) of Greece in 2004 and the Aid flow (current US$) of Luxembourg in 2009?
Provide a succinct answer. 5.22e+06. What is the difference between the Aid flow (current US$) in Greece in 2004 and the Aid flow (current US$) in Australia in 2009?
Give a very brief answer. -2.03e+07. What is the difference between the Aid flow (current US$) of Greece in 2004 and the Aid flow (current US$) of Finland in 2009?
Provide a succinct answer. 2.63e+06. What is the difference between the Aid flow (current US$) in Luxembourg in 2004 and the Aid flow (current US$) in Australia in 2009?
Ensure brevity in your answer.  -2.66e+07. What is the difference between the Aid flow (current US$) of Luxembourg in 2004 and the Aid flow (current US$) of Finland in 2009?
Offer a terse response. -3.68e+06. What is the difference between the Aid flow (current US$) of Australia in 2004 and the Aid flow (current US$) of Finland in 2009?
Your answer should be very brief. 4.58e+06. What is the difference between the Aid flow (current US$) of Greece in 2005 and the Aid flow (current US$) of Luxembourg in 2006?
Keep it short and to the point. 2.29e+07. What is the difference between the Aid flow (current US$) in Greece in 2005 and the Aid flow (current US$) in Australia in 2006?
Offer a very short reply. -1.83e+07. What is the difference between the Aid flow (current US$) in Greece in 2005 and the Aid flow (current US$) in Finland in 2006?
Give a very brief answer. 2.33e+07. What is the difference between the Aid flow (current US$) in Luxembourg in 2005 and the Aid flow (current US$) in Australia in 2006?
Ensure brevity in your answer.  -3.96e+07. What is the difference between the Aid flow (current US$) of Luxembourg in 2005 and the Aid flow (current US$) of Finland in 2006?
Keep it short and to the point. 2.08e+06. What is the difference between the Aid flow (current US$) of Australia in 2005 and the Aid flow (current US$) of Finland in 2006?
Provide a succinct answer. 5.07e+07. What is the difference between the Aid flow (current US$) in Greece in 2005 and the Aid flow (current US$) in Luxembourg in 2007?
Your answer should be very brief. 1.67e+07. What is the difference between the Aid flow (current US$) in Greece in 2005 and the Aid flow (current US$) in Australia in 2007?
Provide a succinct answer. 3.67e+06. What is the difference between the Aid flow (current US$) of Greece in 2005 and the Aid flow (current US$) of Finland in 2007?
Your response must be concise. 2.11e+07. What is the difference between the Aid flow (current US$) in Luxembourg in 2005 and the Aid flow (current US$) in Australia in 2007?
Provide a short and direct response. -1.76e+07. What is the difference between the Aid flow (current US$) in Luxembourg in 2005 and the Aid flow (current US$) in Finland in 2007?
Provide a short and direct response. -1.00e+05. What is the difference between the Aid flow (current US$) in Australia in 2005 and the Aid flow (current US$) in Finland in 2007?
Keep it short and to the point. 4.85e+07. What is the difference between the Aid flow (current US$) in Greece in 2005 and the Aid flow (current US$) in Luxembourg in 2008?
Provide a short and direct response. 1.88e+07. What is the difference between the Aid flow (current US$) of Greece in 2005 and the Aid flow (current US$) of Australia in 2008?
Offer a very short reply. 3.37e+06. What is the difference between the Aid flow (current US$) in Greece in 2005 and the Aid flow (current US$) in Finland in 2008?
Ensure brevity in your answer.  2.18e+07. What is the difference between the Aid flow (current US$) in Luxembourg in 2005 and the Aid flow (current US$) in Australia in 2008?
Ensure brevity in your answer.  -1.79e+07. What is the difference between the Aid flow (current US$) of Luxembourg in 2005 and the Aid flow (current US$) of Finland in 2008?
Your answer should be very brief. 5.80e+05. What is the difference between the Aid flow (current US$) in Australia in 2005 and the Aid flow (current US$) in Finland in 2008?
Provide a short and direct response. 4.92e+07. What is the difference between the Aid flow (current US$) in Greece in 2005 and the Aid flow (current US$) in Luxembourg in 2009?
Your answer should be very brief. 2.10e+07. What is the difference between the Aid flow (current US$) in Greece in 2005 and the Aid flow (current US$) in Australia in 2009?
Your response must be concise. -4.54e+06. What is the difference between the Aid flow (current US$) of Greece in 2005 and the Aid flow (current US$) of Finland in 2009?
Offer a terse response. 1.84e+07. What is the difference between the Aid flow (current US$) of Luxembourg in 2005 and the Aid flow (current US$) of Australia in 2009?
Provide a succinct answer. -2.58e+07. What is the difference between the Aid flow (current US$) of Luxembourg in 2005 and the Aid flow (current US$) of Finland in 2009?
Ensure brevity in your answer.  -2.82e+06. What is the difference between the Aid flow (current US$) of Australia in 2005 and the Aid flow (current US$) of Finland in 2009?
Your answer should be compact. 4.58e+07. What is the difference between the Aid flow (current US$) of Greece in 2006 and the Aid flow (current US$) of Luxembourg in 2007?
Offer a very short reply. 5.31e+06. What is the difference between the Aid flow (current US$) of Greece in 2006 and the Aid flow (current US$) of Australia in 2007?
Ensure brevity in your answer.  -7.75e+06. What is the difference between the Aid flow (current US$) of Greece in 2006 and the Aid flow (current US$) of Finland in 2007?
Provide a short and direct response. 9.71e+06. What is the difference between the Aid flow (current US$) in Luxembourg in 2006 and the Aid flow (current US$) in Australia in 2007?
Your answer should be very brief. -1.92e+07. What is the difference between the Aid flow (current US$) in Luxembourg in 2006 and the Aid flow (current US$) in Finland in 2007?
Offer a very short reply. -1.73e+06. What is the difference between the Aid flow (current US$) in Australia in 2006 and the Aid flow (current US$) in Finland in 2007?
Your answer should be compact. 3.95e+07. What is the difference between the Aid flow (current US$) of Greece in 2006 and the Aid flow (current US$) of Luxembourg in 2008?
Ensure brevity in your answer.  7.42e+06. What is the difference between the Aid flow (current US$) in Greece in 2006 and the Aid flow (current US$) in Australia in 2008?
Your answer should be compact. -8.05e+06. What is the difference between the Aid flow (current US$) of Greece in 2006 and the Aid flow (current US$) of Finland in 2008?
Offer a terse response. 1.04e+07. What is the difference between the Aid flow (current US$) in Luxembourg in 2006 and the Aid flow (current US$) in Australia in 2008?
Your answer should be compact. -1.95e+07. What is the difference between the Aid flow (current US$) in Luxembourg in 2006 and the Aid flow (current US$) in Finland in 2008?
Keep it short and to the point. -1.05e+06. What is the difference between the Aid flow (current US$) in Australia in 2006 and the Aid flow (current US$) in Finland in 2008?
Make the answer very short. 4.02e+07. What is the difference between the Aid flow (current US$) in Greece in 2006 and the Aid flow (current US$) in Luxembourg in 2009?
Your response must be concise. 9.58e+06. What is the difference between the Aid flow (current US$) in Greece in 2006 and the Aid flow (current US$) in Australia in 2009?
Offer a terse response. -1.60e+07. What is the difference between the Aid flow (current US$) in Greece in 2006 and the Aid flow (current US$) in Finland in 2009?
Your answer should be very brief. 6.99e+06. What is the difference between the Aid flow (current US$) in Luxembourg in 2006 and the Aid flow (current US$) in Australia in 2009?
Ensure brevity in your answer.  -2.74e+07. What is the difference between the Aid flow (current US$) of Luxembourg in 2006 and the Aid flow (current US$) of Finland in 2009?
Your answer should be compact. -4.45e+06. What is the difference between the Aid flow (current US$) in Australia in 2006 and the Aid flow (current US$) in Finland in 2009?
Provide a succinct answer. 3.68e+07. What is the difference between the Aid flow (current US$) of Greece in 2007 and the Aid flow (current US$) of Luxembourg in 2008?
Keep it short and to the point. 1.60e+07. What is the difference between the Aid flow (current US$) of Greece in 2007 and the Aid flow (current US$) of Australia in 2008?
Keep it short and to the point. 5.10e+05. What is the difference between the Aid flow (current US$) of Greece in 2007 and the Aid flow (current US$) of Finland in 2008?
Keep it short and to the point. 1.90e+07. What is the difference between the Aid flow (current US$) of Luxembourg in 2007 and the Aid flow (current US$) of Australia in 2008?
Provide a short and direct response. -1.34e+07. What is the difference between the Aid flow (current US$) in Luxembourg in 2007 and the Aid flow (current US$) in Finland in 2008?
Offer a very short reply. 5.08e+06. What is the difference between the Aid flow (current US$) in Australia in 2007 and the Aid flow (current US$) in Finland in 2008?
Provide a short and direct response. 1.81e+07. What is the difference between the Aid flow (current US$) of Greece in 2007 and the Aid flow (current US$) of Luxembourg in 2009?
Ensure brevity in your answer.  1.81e+07. What is the difference between the Aid flow (current US$) in Greece in 2007 and the Aid flow (current US$) in Australia in 2009?
Provide a succinct answer. -7.40e+06. What is the difference between the Aid flow (current US$) of Greece in 2007 and the Aid flow (current US$) of Finland in 2009?
Make the answer very short. 1.56e+07. What is the difference between the Aid flow (current US$) of Luxembourg in 2007 and the Aid flow (current US$) of Australia in 2009?
Provide a succinct answer. -2.13e+07. What is the difference between the Aid flow (current US$) in Luxembourg in 2007 and the Aid flow (current US$) in Finland in 2009?
Your answer should be compact. 1.68e+06. What is the difference between the Aid flow (current US$) of Australia in 2007 and the Aid flow (current US$) of Finland in 2009?
Make the answer very short. 1.47e+07. What is the difference between the Aid flow (current US$) of Greece in 2008 and the Aid flow (current US$) of Luxembourg in 2009?
Give a very brief answer. 1.02e+07. What is the difference between the Aid flow (current US$) in Greece in 2008 and the Aid flow (current US$) in Australia in 2009?
Provide a short and direct response. -1.54e+07. What is the difference between the Aid flow (current US$) of Greece in 2008 and the Aid flow (current US$) of Finland in 2009?
Ensure brevity in your answer.  7.58e+06. What is the difference between the Aid flow (current US$) of Luxembourg in 2008 and the Aid flow (current US$) of Australia in 2009?
Provide a short and direct response. -2.34e+07. What is the difference between the Aid flow (current US$) in Luxembourg in 2008 and the Aid flow (current US$) in Finland in 2009?
Provide a short and direct response. -4.30e+05. What is the difference between the Aid flow (current US$) of Australia in 2008 and the Aid flow (current US$) of Finland in 2009?
Ensure brevity in your answer.  1.50e+07. What is the average Aid flow (current US$) in Greece per year?
Keep it short and to the point. 1.46e+07. What is the average Aid flow (current US$) in Luxembourg per year?
Ensure brevity in your answer.  4.75e+06. What is the average Aid flow (current US$) of Australia per year?
Offer a very short reply. 2.42e+07. What is the average Aid flow (current US$) in Finland per year?
Make the answer very short. 2.61e+06. In the year 2001, what is the difference between the Aid flow (current US$) of Greece and Aid flow (current US$) of Luxembourg?
Ensure brevity in your answer.  -4.00e+04. In the year 2001, what is the difference between the Aid flow (current US$) of Greece and Aid flow (current US$) of Australia?
Keep it short and to the point. -5.12e+06. In the year 2001, what is the difference between the Aid flow (current US$) of Greece and Aid flow (current US$) of Finland?
Ensure brevity in your answer.  2.54e+06. In the year 2001, what is the difference between the Aid flow (current US$) of Luxembourg and Aid flow (current US$) of Australia?
Your answer should be very brief. -5.08e+06. In the year 2001, what is the difference between the Aid flow (current US$) of Luxembourg and Aid flow (current US$) of Finland?
Your answer should be compact. 2.58e+06. In the year 2001, what is the difference between the Aid flow (current US$) in Australia and Aid flow (current US$) in Finland?
Offer a very short reply. 7.66e+06. In the year 2002, what is the difference between the Aid flow (current US$) of Greece and Aid flow (current US$) of Luxembourg?
Make the answer very short. 7.05e+06. In the year 2002, what is the difference between the Aid flow (current US$) in Greece and Aid flow (current US$) in Australia?
Make the answer very short. -1.49e+06. In the year 2002, what is the difference between the Aid flow (current US$) in Greece and Aid flow (current US$) in Finland?
Provide a succinct answer. 7.81e+06. In the year 2002, what is the difference between the Aid flow (current US$) of Luxembourg and Aid flow (current US$) of Australia?
Provide a short and direct response. -8.54e+06. In the year 2002, what is the difference between the Aid flow (current US$) of Luxembourg and Aid flow (current US$) of Finland?
Make the answer very short. 7.60e+05. In the year 2002, what is the difference between the Aid flow (current US$) in Australia and Aid flow (current US$) in Finland?
Your answer should be very brief. 9.30e+06. In the year 2003, what is the difference between the Aid flow (current US$) in Greece and Aid flow (current US$) in Luxembourg?
Ensure brevity in your answer.  4.62e+06. In the year 2003, what is the difference between the Aid flow (current US$) in Greece and Aid flow (current US$) in Australia?
Your answer should be very brief. -4.51e+06. In the year 2003, what is the difference between the Aid flow (current US$) in Greece and Aid flow (current US$) in Finland?
Keep it short and to the point. 7.63e+06. In the year 2003, what is the difference between the Aid flow (current US$) of Luxembourg and Aid flow (current US$) of Australia?
Provide a succinct answer. -9.13e+06. In the year 2003, what is the difference between the Aid flow (current US$) in Luxembourg and Aid flow (current US$) in Finland?
Keep it short and to the point. 3.01e+06. In the year 2003, what is the difference between the Aid flow (current US$) in Australia and Aid flow (current US$) in Finland?
Ensure brevity in your answer.  1.21e+07. In the year 2004, what is the difference between the Aid flow (current US$) of Greece and Aid flow (current US$) of Luxembourg?
Your answer should be very brief. 6.31e+06. In the year 2004, what is the difference between the Aid flow (current US$) of Greece and Aid flow (current US$) of Australia?
Make the answer very short. -1.95e+06. In the year 2004, what is the difference between the Aid flow (current US$) in Greece and Aid flow (current US$) in Finland?
Offer a very short reply. 9.92e+06. In the year 2004, what is the difference between the Aid flow (current US$) of Luxembourg and Aid flow (current US$) of Australia?
Provide a short and direct response. -8.26e+06. In the year 2004, what is the difference between the Aid flow (current US$) in Luxembourg and Aid flow (current US$) in Finland?
Your answer should be very brief. 3.61e+06. In the year 2004, what is the difference between the Aid flow (current US$) in Australia and Aid flow (current US$) in Finland?
Your response must be concise. 1.19e+07. In the year 2005, what is the difference between the Aid flow (current US$) of Greece and Aid flow (current US$) of Luxembourg?
Offer a terse response. 2.12e+07. In the year 2005, what is the difference between the Aid flow (current US$) in Greece and Aid flow (current US$) in Australia?
Give a very brief answer. -2.74e+07. In the year 2005, what is the difference between the Aid flow (current US$) in Greece and Aid flow (current US$) in Finland?
Provide a succinct answer. 2.53e+07. In the year 2005, what is the difference between the Aid flow (current US$) of Luxembourg and Aid flow (current US$) of Australia?
Offer a terse response. -4.86e+07. In the year 2005, what is the difference between the Aid flow (current US$) in Luxembourg and Aid flow (current US$) in Finland?
Your answer should be compact. 4.08e+06. In the year 2005, what is the difference between the Aid flow (current US$) in Australia and Aid flow (current US$) in Finland?
Ensure brevity in your answer.  5.27e+07. In the year 2006, what is the difference between the Aid flow (current US$) of Greece and Aid flow (current US$) of Luxembourg?
Make the answer very short. 1.14e+07. In the year 2006, what is the difference between the Aid flow (current US$) of Greece and Aid flow (current US$) of Australia?
Make the answer very short. -2.98e+07. In the year 2006, what is the difference between the Aid flow (current US$) in Greece and Aid flow (current US$) in Finland?
Your answer should be very brief. 1.19e+07. In the year 2006, what is the difference between the Aid flow (current US$) in Luxembourg and Aid flow (current US$) in Australia?
Provide a succinct answer. -4.12e+07. In the year 2006, what is the difference between the Aid flow (current US$) of Luxembourg and Aid flow (current US$) of Finland?
Offer a terse response. 4.50e+05. In the year 2006, what is the difference between the Aid flow (current US$) in Australia and Aid flow (current US$) in Finland?
Offer a terse response. 4.16e+07. In the year 2007, what is the difference between the Aid flow (current US$) of Greece and Aid flow (current US$) of Luxembourg?
Your response must be concise. 1.39e+07. In the year 2007, what is the difference between the Aid flow (current US$) of Greece and Aid flow (current US$) of Australia?
Keep it short and to the point. 8.10e+05. In the year 2007, what is the difference between the Aid flow (current US$) of Greece and Aid flow (current US$) of Finland?
Make the answer very short. 1.83e+07. In the year 2007, what is the difference between the Aid flow (current US$) of Luxembourg and Aid flow (current US$) of Australia?
Ensure brevity in your answer.  -1.31e+07. In the year 2007, what is the difference between the Aid flow (current US$) of Luxembourg and Aid flow (current US$) of Finland?
Your answer should be compact. 4.40e+06. In the year 2007, what is the difference between the Aid flow (current US$) of Australia and Aid flow (current US$) of Finland?
Offer a terse response. 1.75e+07. In the year 2008, what is the difference between the Aid flow (current US$) in Greece and Aid flow (current US$) in Luxembourg?
Keep it short and to the point. 8.01e+06. In the year 2008, what is the difference between the Aid flow (current US$) of Greece and Aid flow (current US$) of Australia?
Offer a terse response. -7.46e+06. In the year 2008, what is the difference between the Aid flow (current US$) of Greece and Aid flow (current US$) of Finland?
Your answer should be compact. 1.10e+07. In the year 2008, what is the difference between the Aid flow (current US$) in Luxembourg and Aid flow (current US$) in Australia?
Provide a short and direct response. -1.55e+07. In the year 2008, what is the difference between the Aid flow (current US$) of Luxembourg and Aid flow (current US$) of Finland?
Your answer should be compact. 2.97e+06. In the year 2008, what is the difference between the Aid flow (current US$) of Australia and Aid flow (current US$) of Finland?
Offer a very short reply. 1.84e+07. In the year 2009, what is the difference between the Aid flow (current US$) of Greece and Aid flow (current US$) of Luxembourg?
Offer a terse response. 1.61e+07. In the year 2009, what is the difference between the Aid flow (current US$) of Greece and Aid flow (current US$) of Australia?
Offer a very short reply. -9.47e+06. In the year 2009, what is the difference between the Aid flow (current US$) of Greece and Aid flow (current US$) of Finland?
Make the answer very short. 1.35e+07. In the year 2009, what is the difference between the Aid flow (current US$) of Luxembourg and Aid flow (current US$) of Australia?
Offer a very short reply. -2.55e+07. In the year 2009, what is the difference between the Aid flow (current US$) of Luxembourg and Aid flow (current US$) of Finland?
Ensure brevity in your answer.  -2.59e+06. In the year 2009, what is the difference between the Aid flow (current US$) of Australia and Aid flow (current US$) of Finland?
Make the answer very short. 2.30e+07. What is the ratio of the Aid flow (current US$) of Greece in 2001 to that in 2002?
Make the answer very short. 0.3. What is the ratio of the Aid flow (current US$) of Luxembourg in 2001 to that in 2002?
Make the answer very short. 1.4. What is the ratio of the Aid flow (current US$) of Australia in 2001 to that in 2002?
Provide a succinct answer. 0.75. What is the ratio of the Aid flow (current US$) in Finland in 2001 to that in 2002?
Give a very brief answer. 0.17. What is the ratio of the Aid flow (current US$) of Greece in 2001 to that in 2003?
Your answer should be very brief. 0.29. What is the ratio of the Aid flow (current US$) in Luxembourg in 2001 to that in 2003?
Keep it short and to the point. 0.56. What is the ratio of the Aid flow (current US$) in Australia in 2001 to that in 2003?
Make the answer very short. 0.56. What is the ratio of the Aid flow (current US$) in Finland in 2001 to that in 2003?
Your answer should be compact. 0.1. What is the ratio of the Aid flow (current US$) in Greece in 2001 to that in 2004?
Keep it short and to the point. 0.27. What is the ratio of the Aid flow (current US$) in Luxembourg in 2001 to that in 2004?
Make the answer very short. 0.72. What is the ratio of the Aid flow (current US$) in Australia in 2001 to that in 2004?
Provide a short and direct response. 0.65. What is the ratio of the Aid flow (current US$) in Finland in 2001 to that in 2004?
Offer a very short reply. 0.84. What is the ratio of the Aid flow (current US$) in Greece in 2001 to that in 2005?
Your response must be concise. 0.11. What is the ratio of the Aid flow (current US$) of Luxembourg in 2001 to that in 2005?
Your answer should be compact. 0.59. What is the ratio of the Aid flow (current US$) of Australia in 2001 to that in 2005?
Your response must be concise. 0.15. What is the ratio of the Aid flow (current US$) of Finland in 2001 to that in 2005?
Offer a terse response. 0.33. What is the ratio of the Aid flow (current US$) of Greece in 2001 to that in 2006?
Keep it short and to the point. 0.19. What is the ratio of the Aid flow (current US$) in Luxembourg in 2001 to that in 2006?
Ensure brevity in your answer.  0.9. What is the ratio of the Aid flow (current US$) in Australia in 2001 to that in 2006?
Your answer should be compact. 0.18. What is the ratio of the Aid flow (current US$) in Finland in 2001 to that in 2006?
Offer a terse response. 0.08. What is the ratio of the Aid flow (current US$) of Greece in 2001 to that in 2007?
Your answer should be compact. 0.12. What is the ratio of the Aid flow (current US$) of Luxembourg in 2001 to that in 2007?
Offer a very short reply. 0.3. What is the ratio of the Aid flow (current US$) in Australia in 2001 to that in 2007?
Ensure brevity in your answer.  0.35. What is the ratio of the Aid flow (current US$) of Finland in 2001 to that in 2007?
Your response must be concise. 0.04. What is the ratio of the Aid flow (current US$) of Greece in 2001 to that in 2008?
Your response must be concise. 0.18. What is the ratio of the Aid flow (current US$) in Luxembourg in 2001 to that in 2008?
Offer a very short reply. 0.39. What is the ratio of the Aid flow (current US$) of Australia in 2001 to that in 2008?
Offer a very short reply. 0.35. What is the ratio of the Aid flow (current US$) of Finland in 2001 to that in 2008?
Your answer should be compact. 0.05. What is the ratio of the Aid flow (current US$) of Greece in 2001 to that in 2009?
Ensure brevity in your answer.  0.13. What is the ratio of the Aid flow (current US$) of Luxembourg in 2001 to that in 2009?
Offer a very short reply. 0.56. What is the ratio of the Aid flow (current US$) in Australia in 2001 to that in 2009?
Ensure brevity in your answer.  0.26. What is the ratio of the Aid flow (current US$) in Finland in 2001 to that in 2009?
Keep it short and to the point. 0.03. What is the ratio of the Aid flow (current US$) in Greece in 2002 to that in 2003?
Provide a succinct answer. 0.94. What is the ratio of the Aid flow (current US$) in Luxembourg in 2002 to that in 2003?
Ensure brevity in your answer.  0.4. What is the ratio of the Aid flow (current US$) in Australia in 2002 to that in 2003?
Ensure brevity in your answer.  0.74. What is the ratio of the Aid flow (current US$) in Finland in 2002 to that in 2003?
Keep it short and to the point. 0.61. What is the ratio of the Aid flow (current US$) in Greece in 2002 to that in 2004?
Provide a succinct answer. 0.89. What is the ratio of the Aid flow (current US$) in Luxembourg in 2002 to that in 2004?
Give a very brief answer. 0.52. What is the ratio of the Aid flow (current US$) of Australia in 2002 to that in 2004?
Provide a short and direct response. 0.87. What is the ratio of the Aid flow (current US$) of Finland in 2002 to that in 2004?
Offer a terse response. 4.92. What is the ratio of the Aid flow (current US$) in Greece in 2002 to that in 2005?
Make the answer very short. 0.35. What is the ratio of the Aid flow (current US$) of Luxembourg in 2002 to that in 2005?
Keep it short and to the point. 0.42. What is the ratio of the Aid flow (current US$) in Australia in 2002 to that in 2005?
Provide a short and direct response. 0.2. What is the ratio of the Aid flow (current US$) in Finland in 2002 to that in 2005?
Your answer should be very brief. 1.92. What is the ratio of the Aid flow (current US$) of Greece in 2002 to that in 2006?
Make the answer very short. 0.62. What is the ratio of the Aid flow (current US$) of Luxembourg in 2002 to that in 2006?
Your response must be concise. 0.64. What is the ratio of the Aid flow (current US$) in Australia in 2002 to that in 2006?
Offer a terse response. 0.24. What is the ratio of the Aid flow (current US$) of Finland in 2002 to that in 2006?
Give a very brief answer. 0.47. What is the ratio of the Aid flow (current US$) in Greece in 2002 to that in 2007?
Offer a very short reply. 0.39. What is the ratio of the Aid flow (current US$) of Luxembourg in 2002 to that in 2007?
Keep it short and to the point. 0.22. What is the ratio of the Aid flow (current US$) of Australia in 2002 to that in 2007?
Ensure brevity in your answer.  0.47. What is the ratio of the Aid flow (current US$) of Finland in 2002 to that in 2007?
Make the answer very short. 0.26. What is the ratio of the Aid flow (current US$) in Greece in 2002 to that in 2008?
Ensure brevity in your answer.  0.6. What is the ratio of the Aid flow (current US$) in Luxembourg in 2002 to that in 2008?
Offer a very short reply. 0.28. What is the ratio of the Aid flow (current US$) in Australia in 2002 to that in 2008?
Your answer should be compact. 0.47. What is the ratio of the Aid flow (current US$) of Finland in 2002 to that in 2008?
Make the answer very short. 0.3. What is the ratio of the Aid flow (current US$) in Greece in 2002 to that in 2009?
Offer a very short reply. 0.43. What is the ratio of the Aid flow (current US$) in Luxembourg in 2002 to that in 2009?
Your answer should be compact. 0.4. What is the ratio of the Aid flow (current US$) of Australia in 2002 to that in 2009?
Keep it short and to the point. 0.35. What is the ratio of the Aid flow (current US$) in Finland in 2002 to that in 2009?
Provide a short and direct response. 0.16. What is the ratio of the Aid flow (current US$) in Greece in 2003 to that in 2004?
Your response must be concise. 0.95. What is the ratio of the Aid flow (current US$) of Luxembourg in 2003 to that in 2004?
Provide a short and direct response. 1.3. What is the ratio of the Aid flow (current US$) of Australia in 2003 to that in 2004?
Offer a terse response. 1.17. What is the ratio of the Aid flow (current US$) of Finland in 2003 to that in 2004?
Keep it short and to the point. 8.04. What is the ratio of the Aid flow (current US$) in Greece in 2003 to that in 2005?
Keep it short and to the point. 0.37. What is the ratio of the Aid flow (current US$) of Luxembourg in 2003 to that in 2005?
Provide a succinct answer. 1.06. What is the ratio of the Aid flow (current US$) of Australia in 2003 to that in 2005?
Provide a succinct answer. 0.27. What is the ratio of the Aid flow (current US$) in Finland in 2003 to that in 2005?
Provide a short and direct response. 3.14. What is the ratio of the Aid flow (current US$) in Greece in 2003 to that in 2006?
Your answer should be compact. 0.66. What is the ratio of the Aid flow (current US$) of Luxembourg in 2003 to that in 2006?
Your answer should be very brief. 1.62. What is the ratio of the Aid flow (current US$) of Australia in 2003 to that in 2006?
Provide a succinct answer. 0.32. What is the ratio of the Aid flow (current US$) of Finland in 2003 to that in 2006?
Your answer should be very brief. 0.76. What is the ratio of the Aid flow (current US$) of Greece in 2003 to that in 2007?
Ensure brevity in your answer.  0.42. What is the ratio of the Aid flow (current US$) of Luxembourg in 2003 to that in 2007?
Ensure brevity in your answer.  0.54. What is the ratio of the Aid flow (current US$) of Australia in 2003 to that in 2007?
Your answer should be compact. 0.64. What is the ratio of the Aid flow (current US$) of Finland in 2003 to that in 2007?
Ensure brevity in your answer.  0.42. What is the ratio of the Aid flow (current US$) of Greece in 2003 to that in 2008?
Ensure brevity in your answer.  0.64. What is the ratio of the Aid flow (current US$) in Luxembourg in 2003 to that in 2008?
Your answer should be compact. 0.71. What is the ratio of the Aid flow (current US$) of Australia in 2003 to that in 2008?
Ensure brevity in your answer.  0.63. What is the ratio of the Aid flow (current US$) of Finland in 2003 to that in 2008?
Give a very brief answer. 0.49. What is the ratio of the Aid flow (current US$) in Greece in 2003 to that in 2009?
Keep it short and to the point. 0.46. What is the ratio of the Aid flow (current US$) in Luxembourg in 2003 to that in 2009?
Ensure brevity in your answer.  1.01. What is the ratio of the Aid flow (current US$) in Australia in 2003 to that in 2009?
Offer a terse response. 0.46. What is the ratio of the Aid flow (current US$) in Finland in 2003 to that in 2009?
Ensure brevity in your answer.  0.27. What is the ratio of the Aid flow (current US$) of Greece in 2004 to that in 2005?
Provide a short and direct response. 0.39. What is the ratio of the Aid flow (current US$) of Luxembourg in 2004 to that in 2005?
Your answer should be compact. 0.82. What is the ratio of the Aid flow (current US$) in Australia in 2004 to that in 2005?
Your answer should be very brief. 0.23. What is the ratio of the Aid flow (current US$) in Finland in 2004 to that in 2005?
Ensure brevity in your answer.  0.39. What is the ratio of the Aid flow (current US$) of Greece in 2004 to that in 2006?
Your answer should be compact. 0.7. What is the ratio of the Aid flow (current US$) in Luxembourg in 2004 to that in 2006?
Ensure brevity in your answer.  1.25. What is the ratio of the Aid flow (current US$) in Australia in 2004 to that in 2006?
Make the answer very short. 0.27. What is the ratio of the Aid flow (current US$) of Finland in 2004 to that in 2006?
Provide a succinct answer. 0.09. What is the ratio of the Aid flow (current US$) of Greece in 2004 to that in 2007?
Make the answer very short. 0.44. What is the ratio of the Aid flow (current US$) of Luxembourg in 2004 to that in 2007?
Offer a terse response. 0.42. What is the ratio of the Aid flow (current US$) of Australia in 2004 to that in 2007?
Give a very brief answer. 0.54. What is the ratio of the Aid flow (current US$) in Finland in 2004 to that in 2007?
Offer a terse response. 0.05. What is the ratio of the Aid flow (current US$) of Greece in 2004 to that in 2008?
Provide a succinct answer. 0.67. What is the ratio of the Aid flow (current US$) of Luxembourg in 2004 to that in 2008?
Keep it short and to the point. 0.54. What is the ratio of the Aid flow (current US$) of Australia in 2004 to that in 2008?
Provide a succinct answer. 0.54. What is the ratio of the Aid flow (current US$) of Finland in 2004 to that in 2008?
Your response must be concise. 0.06. What is the ratio of the Aid flow (current US$) of Greece in 2004 to that in 2009?
Offer a terse response. 0.48. What is the ratio of the Aid flow (current US$) in Luxembourg in 2004 to that in 2009?
Give a very brief answer. 0.78. What is the ratio of the Aid flow (current US$) in Australia in 2004 to that in 2009?
Your answer should be compact. 0.4. What is the ratio of the Aid flow (current US$) of Finland in 2004 to that in 2009?
Make the answer very short. 0.03. What is the ratio of the Aid flow (current US$) of Greece in 2005 to that in 2006?
Offer a terse response. 1.79. What is the ratio of the Aid flow (current US$) of Luxembourg in 2005 to that in 2006?
Ensure brevity in your answer.  1.53. What is the ratio of the Aid flow (current US$) in Australia in 2005 to that in 2006?
Make the answer very short. 1.2. What is the ratio of the Aid flow (current US$) in Finland in 2005 to that in 2006?
Make the answer very short. 0.24. What is the ratio of the Aid flow (current US$) of Greece in 2005 to that in 2007?
Give a very brief answer. 1.12. What is the ratio of the Aid flow (current US$) of Luxembourg in 2005 to that in 2007?
Make the answer very short. 0.51. What is the ratio of the Aid flow (current US$) of Australia in 2005 to that in 2007?
Your answer should be compact. 2.39. What is the ratio of the Aid flow (current US$) in Finland in 2005 to that in 2007?
Offer a very short reply. 0.13. What is the ratio of the Aid flow (current US$) in Greece in 2005 to that in 2008?
Offer a terse response. 1.72. What is the ratio of the Aid flow (current US$) in Luxembourg in 2005 to that in 2008?
Make the answer very short. 0.66. What is the ratio of the Aid flow (current US$) in Australia in 2005 to that in 2008?
Provide a short and direct response. 2.36. What is the ratio of the Aid flow (current US$) in Finland in 2005 to that in 2008?
Keep it short and to the point. 0.15. What is the ratio of the Aid flow (current US$) in Greece in 2005 to that in 2009?
Ensure brevity in your answer.  1.23. What is the ratio of the Aid flow (current US$) in Luxembourg in 2005 to that in 2009?
Ensure brevity in your answer.  0.95. What is the ratio of the Aid flow (current US$) in Australia in 2005 to that in 2009?
Offer a terse response. 1.75. What is the ratio of the Aid flow (current US$) in Finland in 2005 to that in 2009?
Provide a short and direct response. 0.08. What is the ratio of the Aid flow (current US$) of Greece in 2006 to that in 2007?
Offer a very short reply. 0.63. What is the ratio of the Aid flow (current US$) of Luxembourg in 2006 to that in 2007?
Your answer should be very brief. 0.34. What is the ratio of the Aid flow (current US$) in Australia in 2006 to that in 2007?
Your response must be concise. 1.99. What is the ratio of the Aid flow (current US$) in Finland in 2006 to that in 2007?
Ensure brevity in your answer.  0.55. What is the ratio of the Aid flow (current US$) of Luxembourg in 2006 to that in 2008?
Your answer should be compact. 0.43. What is the ratio of the Aid flow (current US$) of Australia in 2006 to that in 2008?
Ensure brevity in your answer.  1.96. What is the ratio of the Aid flow (current US$) in Finland in 2006 to that in 2008?
Provide a short and direct response. 0.64. What is the ratio of the Aid flow (current US$) of Greece in 2006 to that in 2009?
Make the answer very short. 0.69. What is the ratio of the Aid flow (current US$) of Luxembourg in 2006 to that in 2009?
Your answer should be very brief. 0.62. What is the ratio of the Aid flow (current US$) in Australia in 2006 to that in 2009?
Make the answer very short. 1.45. What is the ratio of the Aid flow (current US$) in Finland in 2006 to that in 2009?
Ensure brevity in your answer.  0.35. What is the ratio of the Aid flow (current US$) in Greece in 2007 to that in 2008?
Keep it short and to the point. 1.53. What is the ratio of the Aid flow (current US$) in Luxembourg in 2007 to that in 2008?
Give a very brief answer. 1.3. What is the ratio of the Aid flow (current US$) of Australia in 2007 to that in 2008?
Offer a terse response. 0.99. What is the ratio of the Aid flow (current US$) in Finland in 2007 to that in 2008?
Ensure brevity in your answer.  1.16. What is the ratio of the Aid flow (current US$) in Greece in 2007 to that in 2009?
Your answer should be compact. 1.1. What is the ratio of the Aid flow (current US$) of Luxembourg in 2007 to that in 2009?
Provide a succinct answer. 1.86. What is the ratio of the Aid flow (current US$) of Australia in 2007 to that in 2009?
Your answer should be compact. 0.73. What is the ratio of the Aid flow (current US$) in Finland in 2007 to that in 2009?
Ensure brevity in your answer.  0.64. What is the ratio of the Aid flow (current US$) in Greece in 2008 to that in 2009?
Give a very brief answer. 0.72. What is the ratio of the Aid flow (current US$) of Luxembourg in 2008 to that in 2009?
Offer a terse response. 1.44. What is the ratio of the Aid flow (current US$) of Australia in 2008 to that in 2009?
Provide a short and direct response. 0.74. What is the ratio of the Aid flow (current US$) of Finland in 2008 to that in 2009?
Provide a succinct answer. 0.55. What is the difference between the highest and the second highest Aid flow (current US$) in Greece?
Provide a short and direct response. 2.86e+06. What is the difference between the highest and the second highest Aid flow (current US$) in Luxembourg?
Ensure brevity in your answer.  2.11e+06. What is the difference between the highest and the second highest Aid flow (current US$) of Australia?
Provide a short and direct response. 9.05e+06. What is the difference between the highest and the second highest Aid flow (current US$) of Finland?
Provide a short and direct response. 2.72e+06. What is the difference between the highest and the lowest Aid flow (current US$) in Greece?
Give a very brief answer. 2.32e+07. What is the difference between the highest and the lowest Aid flow (current US$) of Luxembourg?
Your answer should be very brief. 7.23e+06. What is the difference between the highest and the lowest Aid flow (current US$) of Australia?
Provide a succinct answer. 4.55e+07. What is the difference between the highest and the lowest Aid flow (current US$) of Finland?
Your answer should be compact. 7.33e+06. 